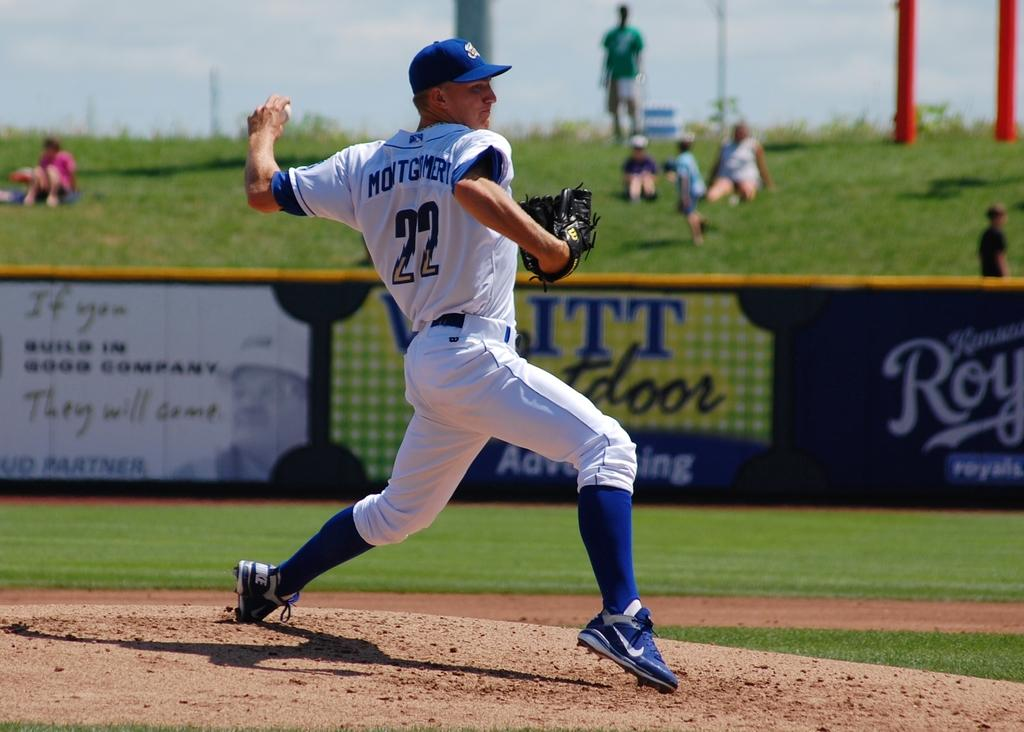<image>
Provide a brief description of the given image. Baseball player wearing number 22 pitching at the plate. 